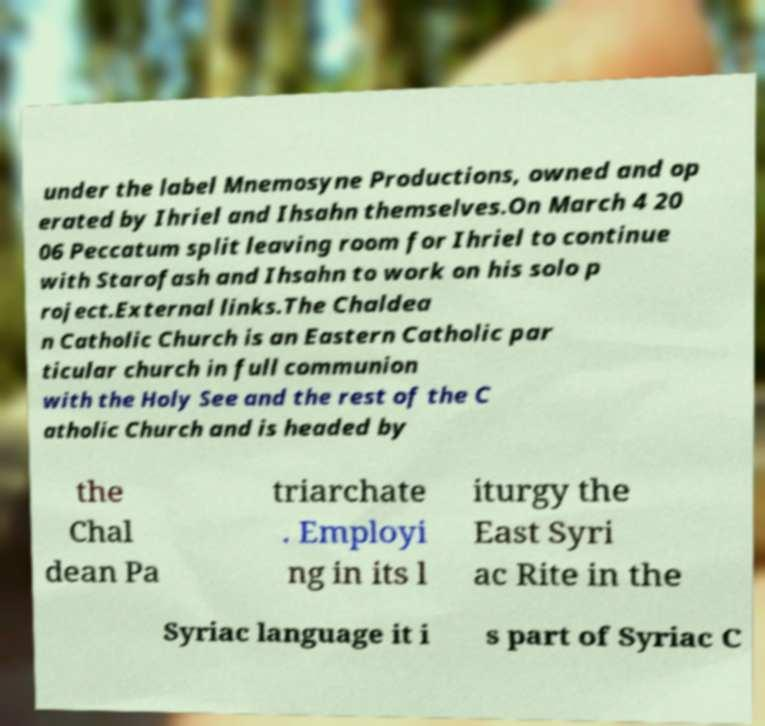There's text embedded in this image that I need extracted. Can you transcribe it verbatim? under the label Mnemosyne Productions, owned and op erated by Ihriel and Ihsahn themselves.On March 4 20 06 Peccatum split leaving room for Ihriel to continue with Starofash and Ihsahn to work on his solo p roject.External links.The Chaldea n Catholic Church is an Eastern Catholic par ticular church in full communion with the Holy See and the rest of the C atholic Church and is headed by the Chal dean Pa triarchate . Employi ng in its l iturgy the East Syri ac Rite in the Syriac language it i s part of Syriac C 